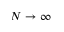<formula> <loc_0><loc_0><loc_500><loc_500>N \to \infty</formula> 